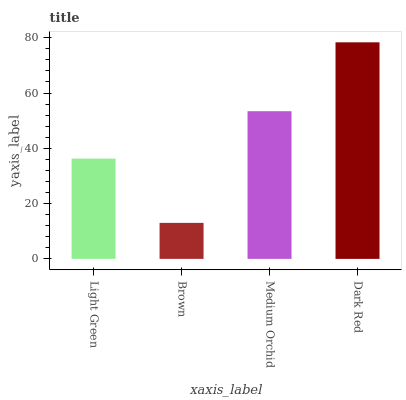Is Brown the minimum?
Answer yes or no. Yes. Is Dark Red the maximum?
Answer yes or no. Yes. Is Medium Orchid the minimum?
Answer yes or no. No. Is Medium Orchid the maximum?
Answer yes or no. No. Is Medium Orchid greater than Brown?
Answer yes or no. Yes. Is Brown less than Medium Orchid?
Answer yes or no. Yes. Is Brown greater than Medium Orchid?
Answer yes or no. No. Is Medium Orchid less than Brown?
Answer yes or no. No. Is Medium Orchid the high median?
Answer yes or no. Yes. Is Light Green the low median?
Answer yes or no. Yes. Is Light Green the high median?
Answer yes or no. No. Is Brown the low median?
Answer yes or no. No. 